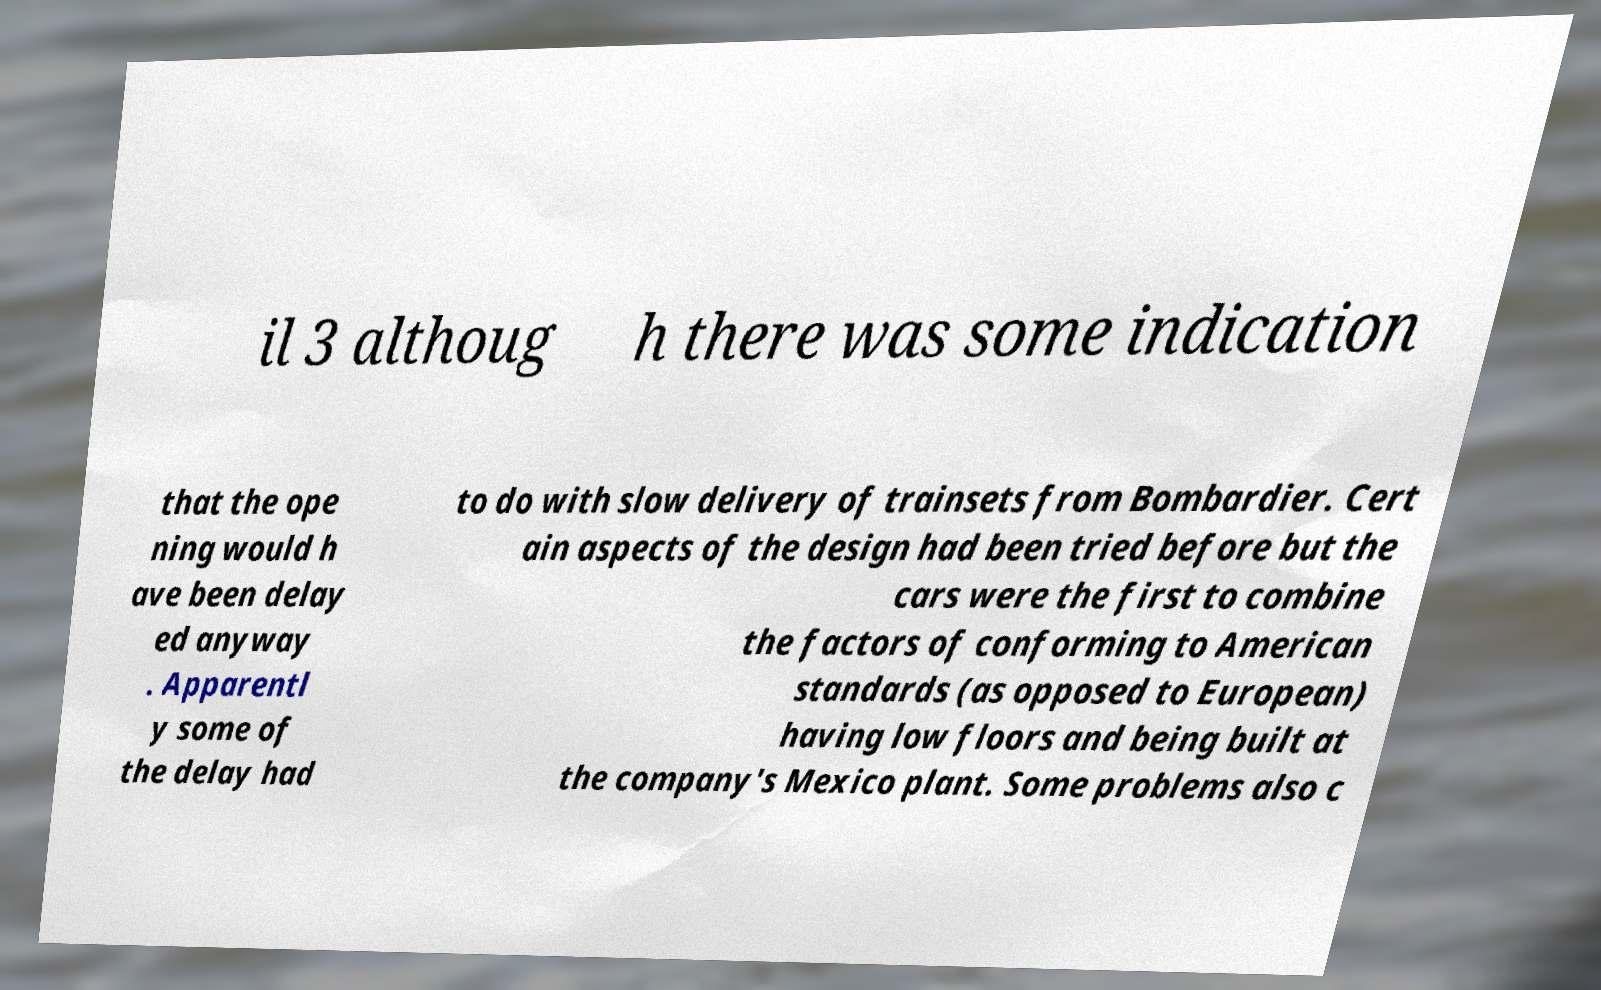Please read and relay the text visible in this image. What does it say? il 3 althoug h there was some indication that the ope ning would h ave been delay ed anyway . Apparentl y some of the delay had to do with slow delivery of trainsets from Bombardier. Cert ain aspects of the design had been tried before but the cars were the first to combine the factors of conforming to American standards (as opposed to European) having low floors and being built at the company's Mexico plant. Some problems also c 